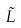Convert formula to latex. <formula><loc_0><loc_0><loc_500><loc_500>\tilde { L }</formula> 